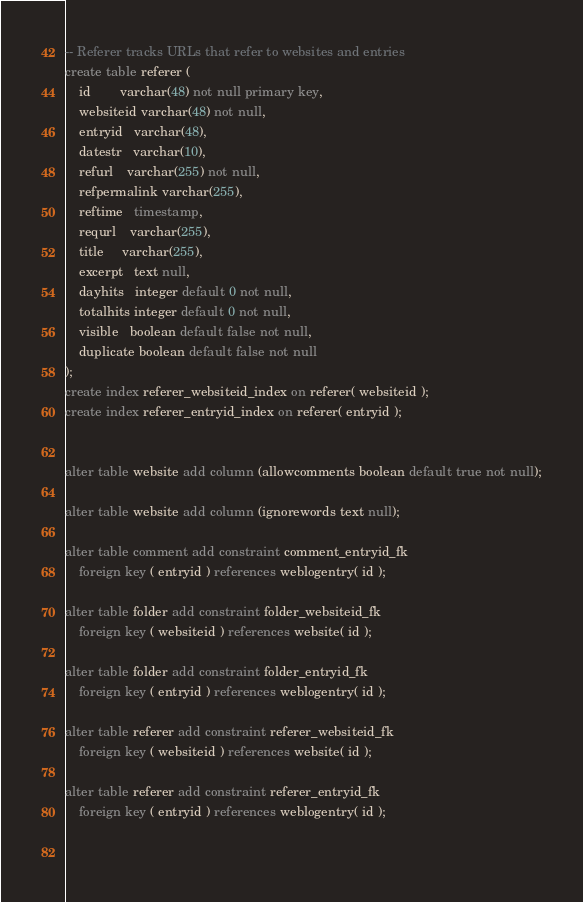Convert code to text. <code><loc_0><loc_0><loc_500><loc_500><_SQL_>

-- Referer tracks URLs that refer to websites and entries
create table referer (
    id        varchar(48) not null primary key,
    websiteid varchar(48) not null,
    entryid   varchar(48),
    datestr   varchar(10),
    refurl    varchar(255) not null,    
    refpermalink varchar(255),    
    reftime   timestamp,
    requrl    varchar(255),    
    title     varchar(255),    
    excerpt   text null,
    dayhits   integer default 0 not null,
    totalhits integer default 0 not null,    
    visible   boolean default false not null,
    duplicate boolean default false not null
);
create index referer_websiteid_index on referer( websiteid );
create index referer_entryid_index on referer( entryid );

  
alter table website add column (allowcomments boolean default true not null);

alter table website add column (ignorewords text null);

alter table comment add constraint comment_entryid_fk 
    foreign key ( entryid ) references weblogentry( id );

alter table folder add constraint folder_websiteid_fk 
    foreign key ( websiteid ) references website( id );
    
alter table folder add constraint folder_entryid_fk 
    foreign key ( entryid ) references weblogentry( id );
    
alter table referer add constraint referer_websiteid_fk 
    foreign key ( websiteid ) references website( id );
    
alter table referer add constraint referer_entryid_fk 
    foreign key ( entryid ) references weblogentry( id );

  </code> 